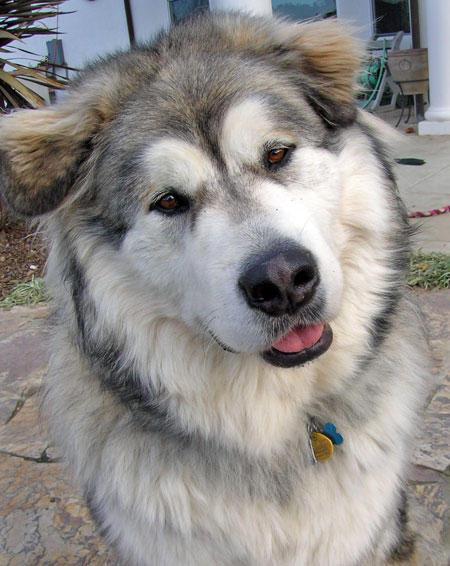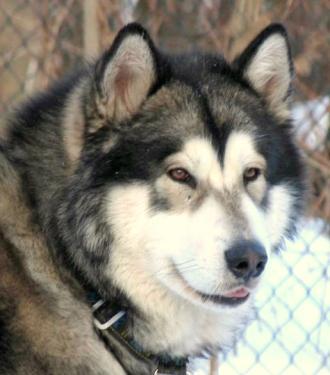The first image is the image on the left, the second image is the image on the right. Given the left and right images, does the statement "The right image features a dog with dark fur framing a white-furred face and snow on some of its fur." hold true? Answer yes or no. No. The first image is the image on the left, the second image is the image on the right. Analyze the images presented: Is the assertion "There is exactly one dog outside in the snow in every photo, and both dogs either have their mouths closed or they both have them open." valid? Answer yes or no. No. 